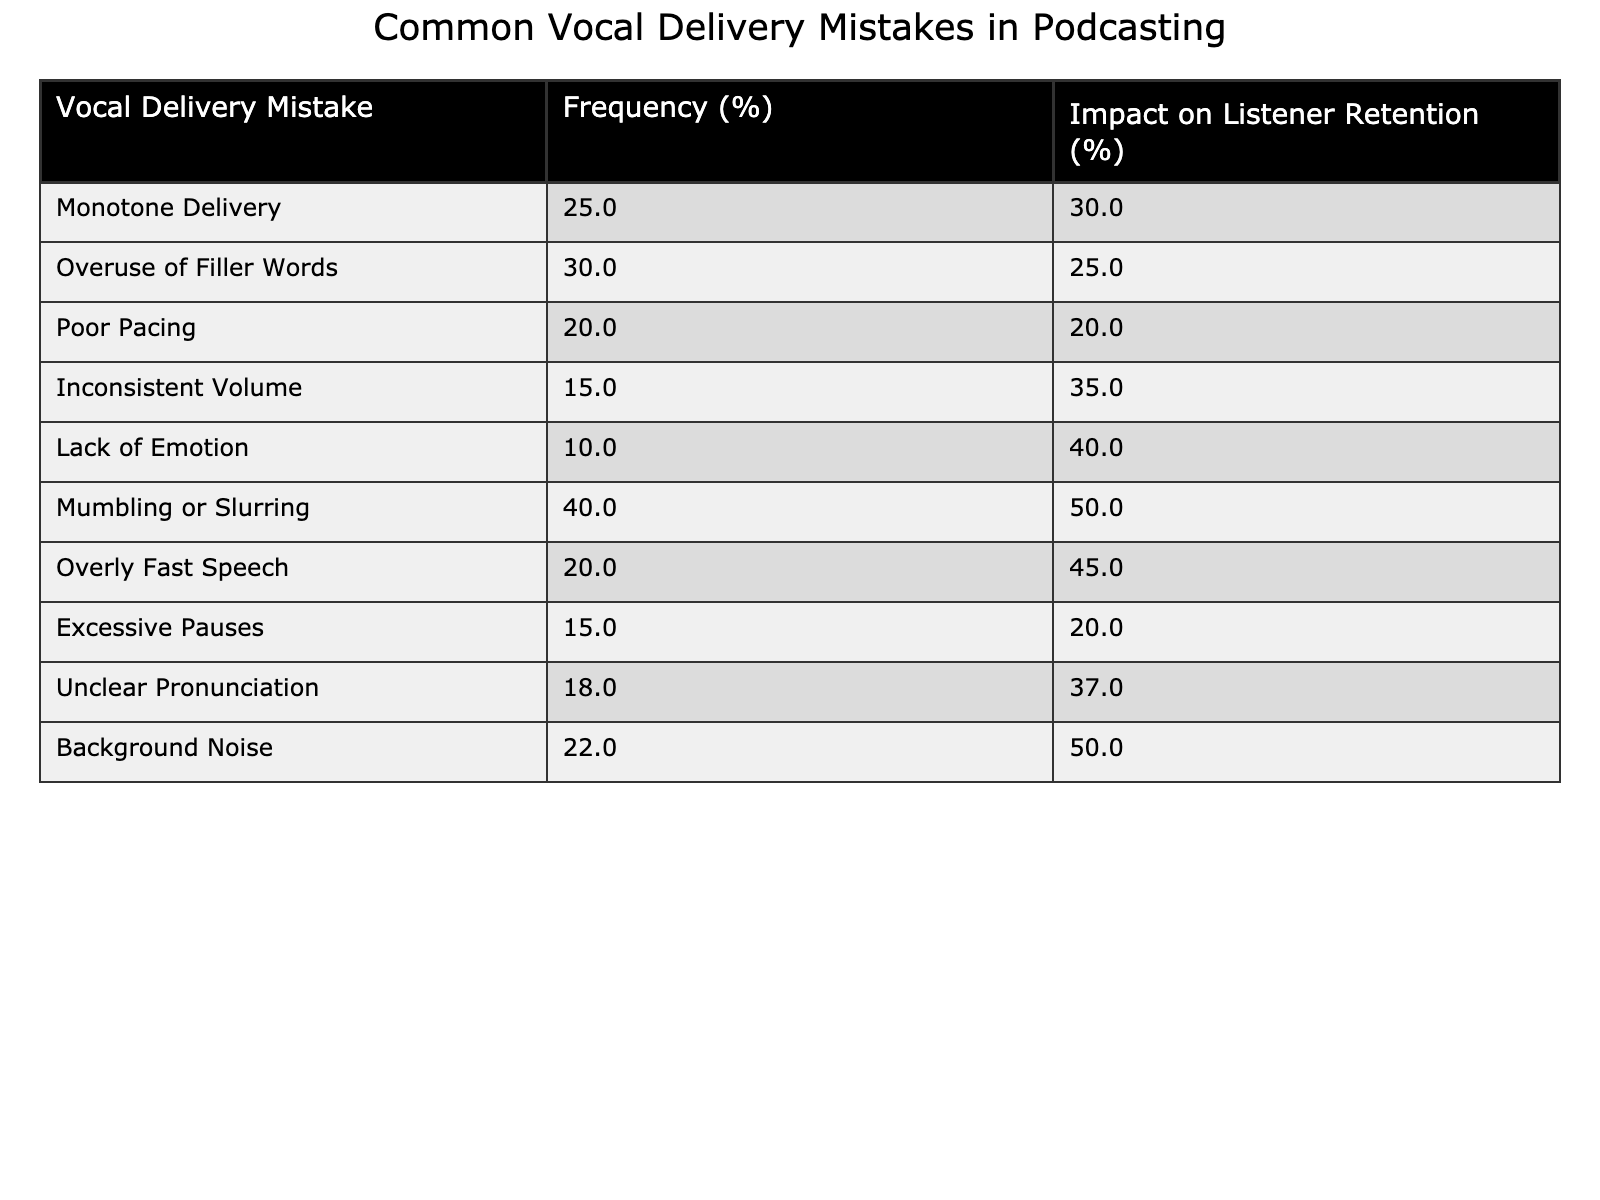What is the frequency percentage of mumbling or slurring mistakes? The table shows that the frequency percentage for mumbling or slurring is listed directly in the corresponding row, which indicates it is 40%.
Answer: 40% What is the impact of poor pacing on listener retention? According to the table, poor pacing affects listener retention by 20%, as indicated in the row specifically for that mistake.
Answer: 20% Which vocal delivery mistake has the highest impact on listener retention, and what is that percentage? The table indicates that mumbling or slurring mistakes have the highest percentage impact on listener retention at 50%.
Answer: 50% How many mistakes have a frequency of 20% or lower? The mistakes with a frequency of 20% or lower in the table include poor pacing (20%), excessive pauses (15%), and inconsistent volume (15%). That's three mistakes in total.
Answer: 3 What is the average impact on listener retention for all the mistakes listed in the table? To calculate the average impact, sum up the impact percentages: 30 + 25 + 20 + 35 + 40 + 50 + 45 + 20 + 37 + 50 =  352, and divide by the number of mistakes (10), which gives us 35.2%.
Answer: 35.2% Is there any mistake that has both high frequency and a high impact on listener retention? Yes, mumbling or slurring has the highest frequency at 40% and the highest impact at 50%, indicating it is a significant issue that affects listener retention.
Answer: Yes What is the difference in listener retention impact between overuse of filler words and lack of emotion? The impact of filler words is 25% and lack of emotion is 40%. The difference is 40 - 25 = 15%, indicating that the lack of emotion has a greater negative effect on listener retention.
Answer: 15% List the mistakes that impact listener retention by 40% or higher. The mistakes that impact listener retention by 40% or higher are mumbling or slurring (50%) and lack of emotion (40%).
Answer: Mumbling or slurring, lack of emotion Which mistake has the second-highest frequency percentage? The mistake with the second-highest frequency percentage is overuse of filler words, which stands at 30%.
Answer: 30% If a podcaster wants to improve retention, should they focus on reducing background noise or mumbling/slurring? The table shows mumbling or slurring has a higher impact on retention (50%) compared to background noise (50%). Although they are tied, focusing on mumbling/slurring may also improve frequency.
Answer: Mumbling/slurring 